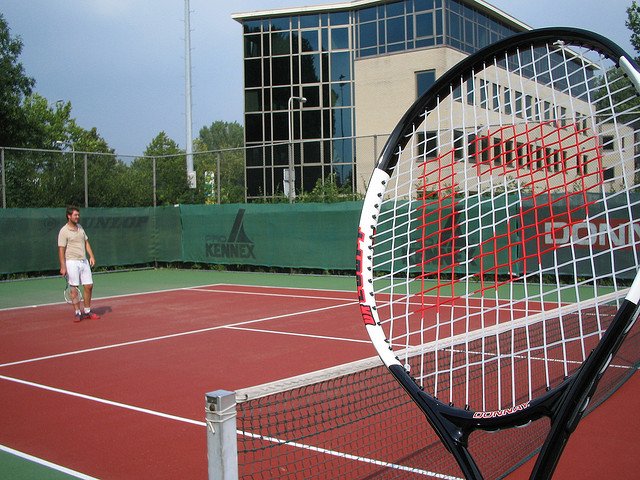Please explain the scoring system in this sport. Tennis has a unique scoring system. Games are scored as follows: no points 'love,' first point '15,' second point '30,' third point '40,' and the fourth point wins the game, unless both players have won three points ('deuce'), then a player must win by two clear points. Sets are composed of games, and matches are usually best of three or five sets. 